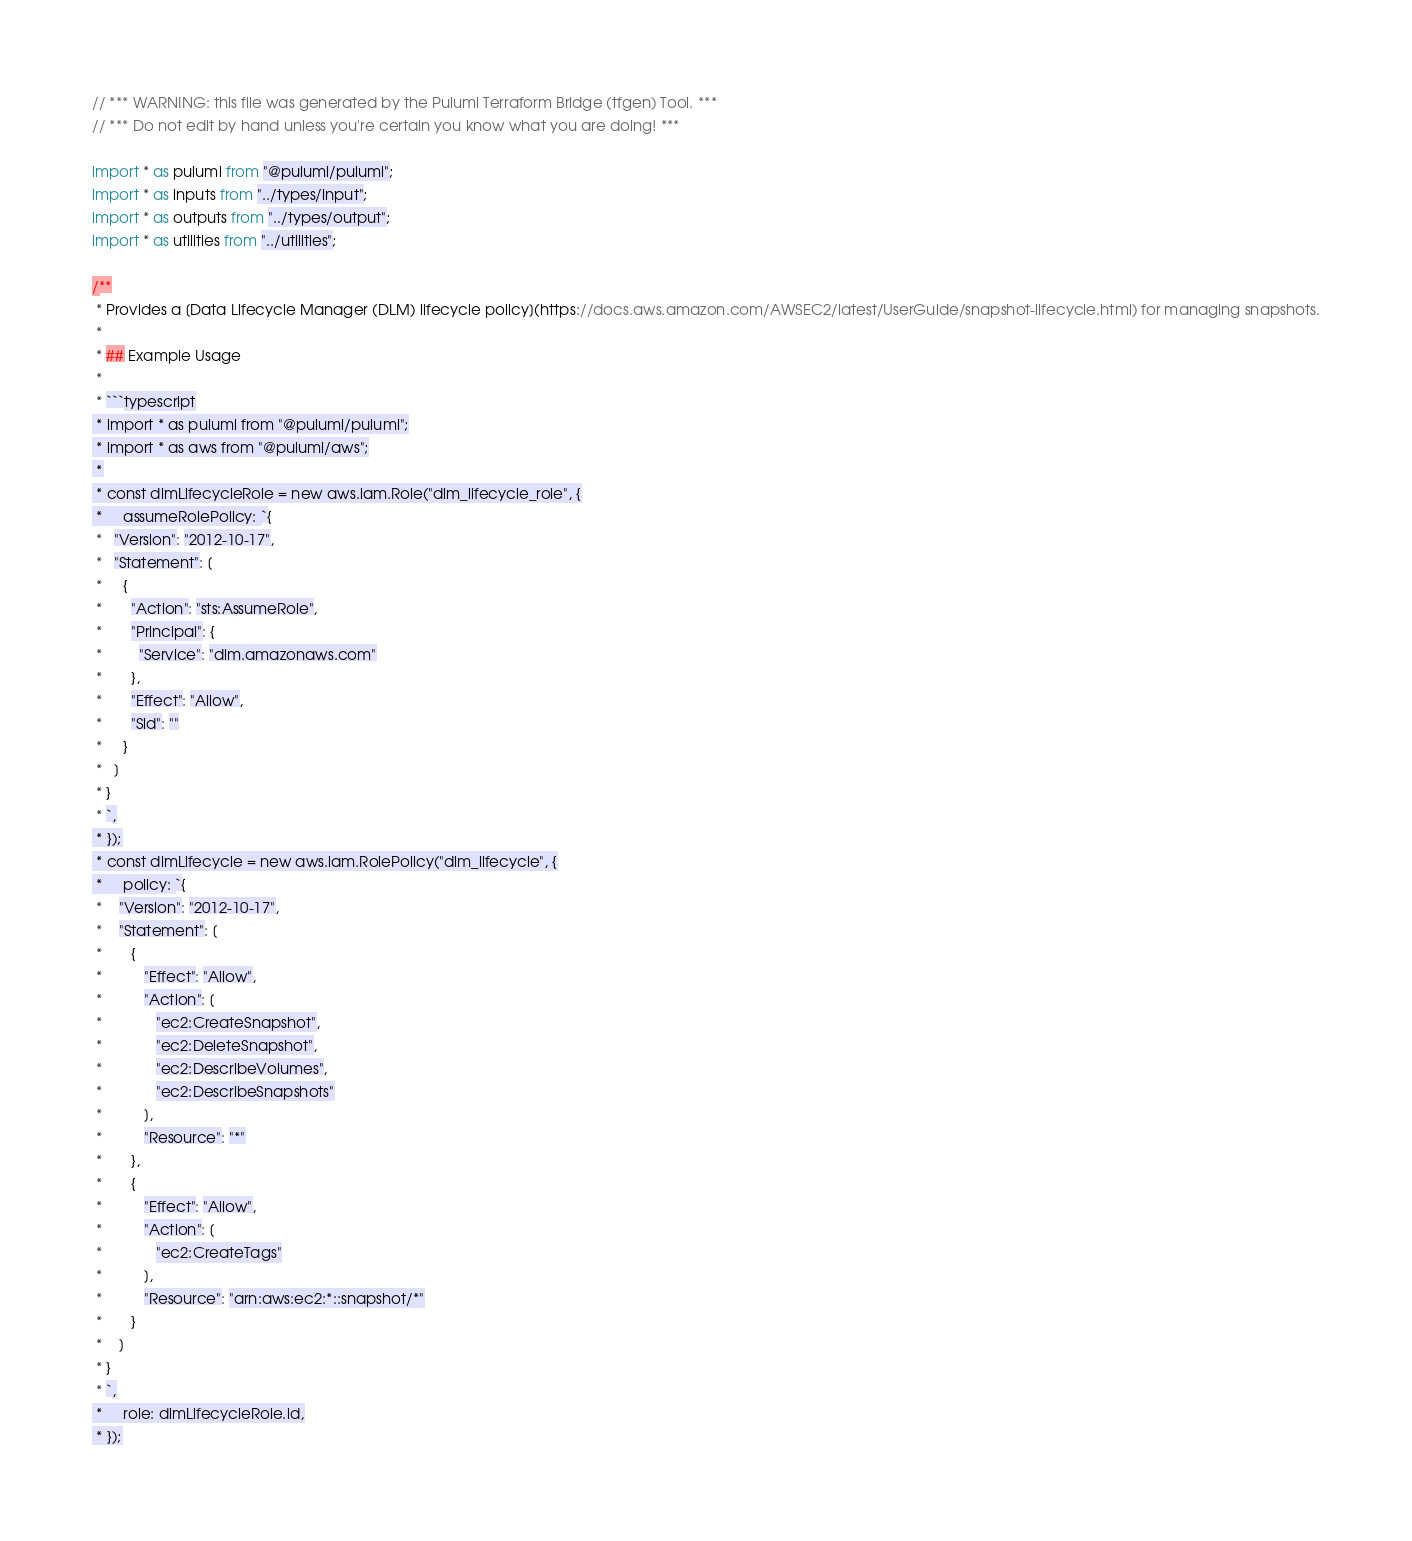Convert code to text. <code><loc_0><loc_0><loc_500><loc_500><_TypeScript_>// *** WARNING: this file was generated by the Pulumi Terraform Bridge (tfgen) Tool. ***
// *** Do not edit by hand unless you're certain you know what you are doing! ***

import * as pulumi from "@pulumi/pulumi";
import * as inputs from "../types/input";
import * as outputs from "../types/output";
import * as utilities from "../utilities";

/**
 * Provides a [Data Lifecycle Manager (DLM) lifecycle policy](https://docs.aws.amazon.com/AWSEC2/latest/UserGuide/snapshot-lifecycle.html) for managing snapshots.
 *
 * ## Example Usage
 *
 * ```typescript
 * import * as pulumi from "@pulumi/pulumi";
 * import * as aws from "@pulumi/aws";
 *
 * const dlmLifecycleRole = new aws.iam.Role("dlm_lifecycle_role", {
 *     assumeRolePolicy: `{
 *   "Version": "2012-10-17",
 *   "Statement": [
 *     {
 *       "Action": "sts:AssumeRole",
 *       "Principal": {
 *         "Service": "dlm.amazonaws.com"
 *       },
 *       "Effect": "Allow",
 *       "Sid": ""
 *     }
 *   ]
 * }
 * `,
 * });
 * const dlmLifecycle = new aws.iam.RolePolicy("dlm_lifecycle", {
 *     policy: `{
 *    "Version": "2012-10-17",
 *    "Statement": [
 *       {
 *          "Effect": "Allow",
 *          "Action": [
 *             "ec2:CreateSnapshot",
 *             "ec2:DeleteSnapshot",
 *             "ec2:DescribeVolumes",
 *             "ec2:DescribeSnapshots"
 *          ],
 *          "Resource": "*"
 *       },
 *       {
 *          "Effect": "Allow",
 *          "Action": [
 *             "ec2:CreateTags"
 *          ],
 *          "Resource": "arn:aws:ec2:*::snapshot/*"
 *       }
 *    ]
 * }
 * `,
 *     role: dlmLifecycleRole.id,
 * });</code> 